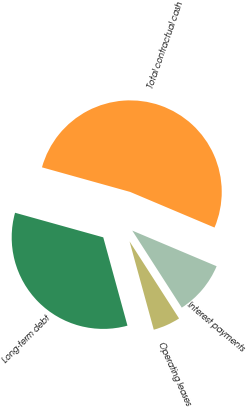<chart> <loc_0><loc_0><loc_500><loc_500><pie_chart><fcel>Long-term debt<fcel>Operating leases<fcel>Interest payments<fcel>Total contractual cash<nl><fcel>33.59%<fcel>4.83%<fcel>9.55%<fcel>52.03%<nl></chart> 